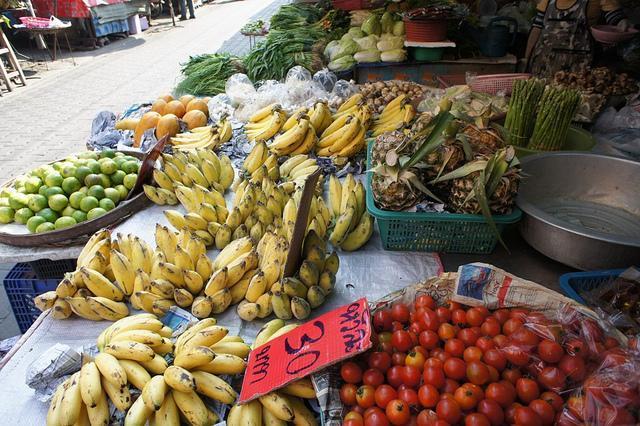How many different types of fruit are there?
Give a very brief answer. 4. How many bananas are visible?
Give a very brief answer. 5. How many black umbrella are there?
Give a very brief answer. 0. 